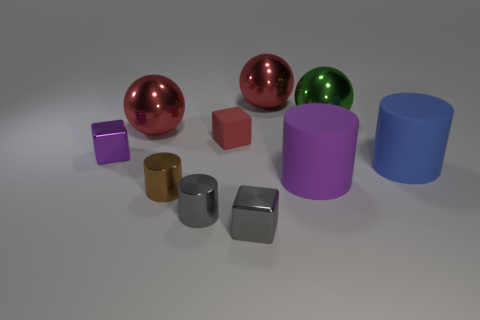Subtract all green blocks. How many red spheres are left? 2 Subtract all blue cylinders. How many cylinders are left? 3 Subtract all blue cylinders. How many cylinders are left? 3 Subtract 1 spheres. How many spheres are left? 2 Subtract all gray cylinders. Subtract all green balls. How many cylinders are left? 3 Subtract all cubes. How many objects are left? 7 Add 8 large green shiny balls. How many large green shiny balls exist? 9 Subtract 0 cyan spheres. How many objects are left? 10 Subtract all red blocks. Subtract all green objects. How many objects are left? 8 Add 4 small brown cylinders. How many small brown cylinders are left? 5 